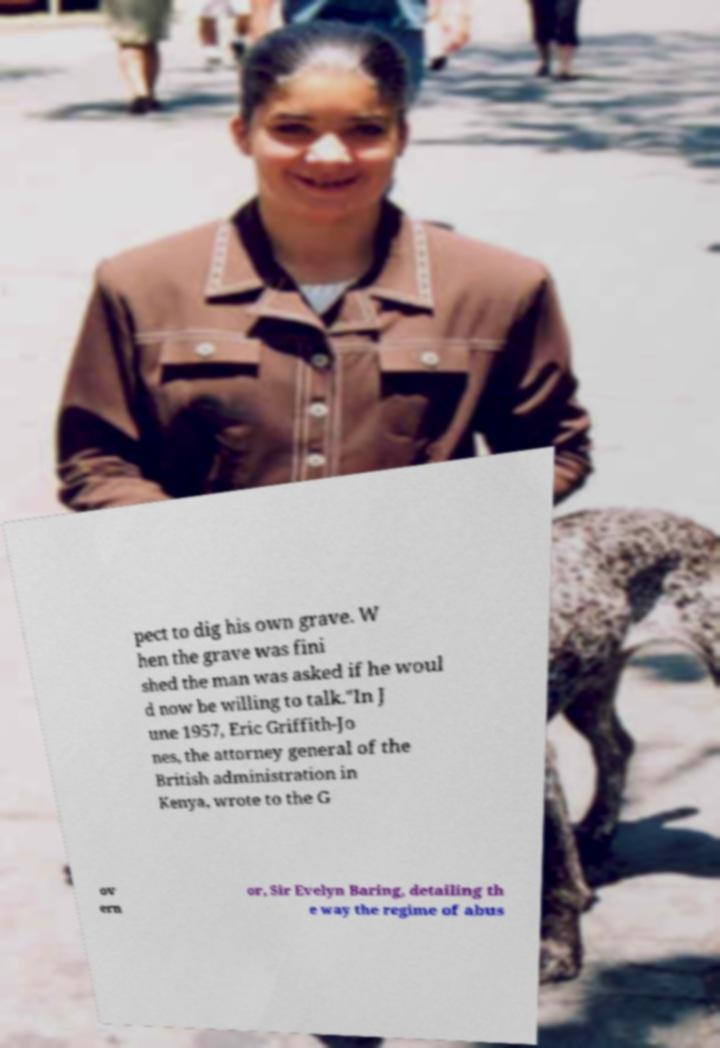For documentation purposes, I need the text within this image transcribed. Could you provide that? pect to dig his own grave. W hen the grave was fini shed the man was asked if he woul d now be willing to talk."In J une 1957, Eric Griffith-Jo nes, the attorney general of the British administration in Kenya, wrote to the G ov ern or, Sir Evelyn Baring, detailing th e way the regime of abus 